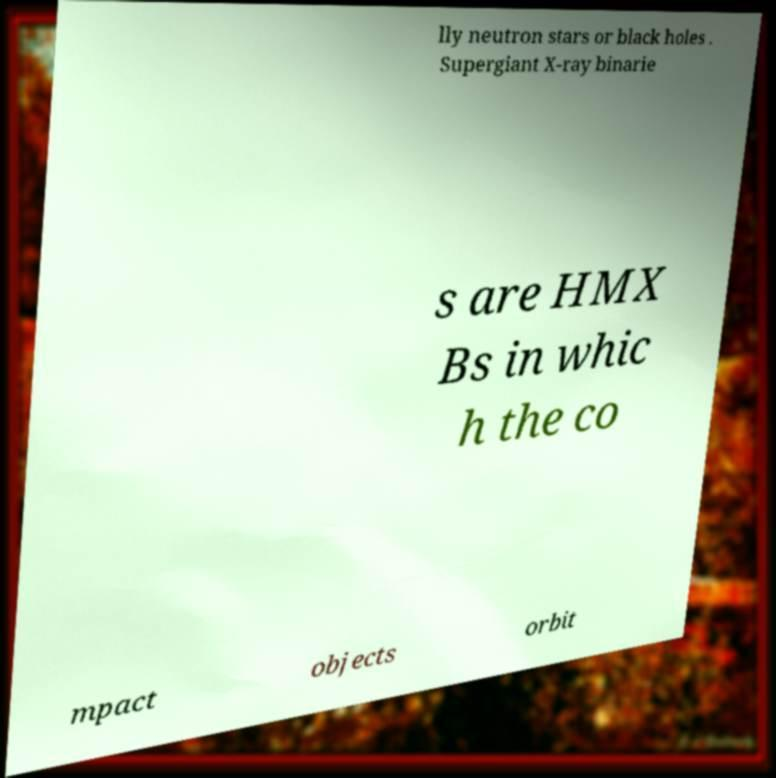What messages or text are displayed in this image? I need them in a readable, typed format. lly neutron stars or black holes . Supergiant X-ray binarie s are HMX Bs in whic h the co mpact objects orbit 